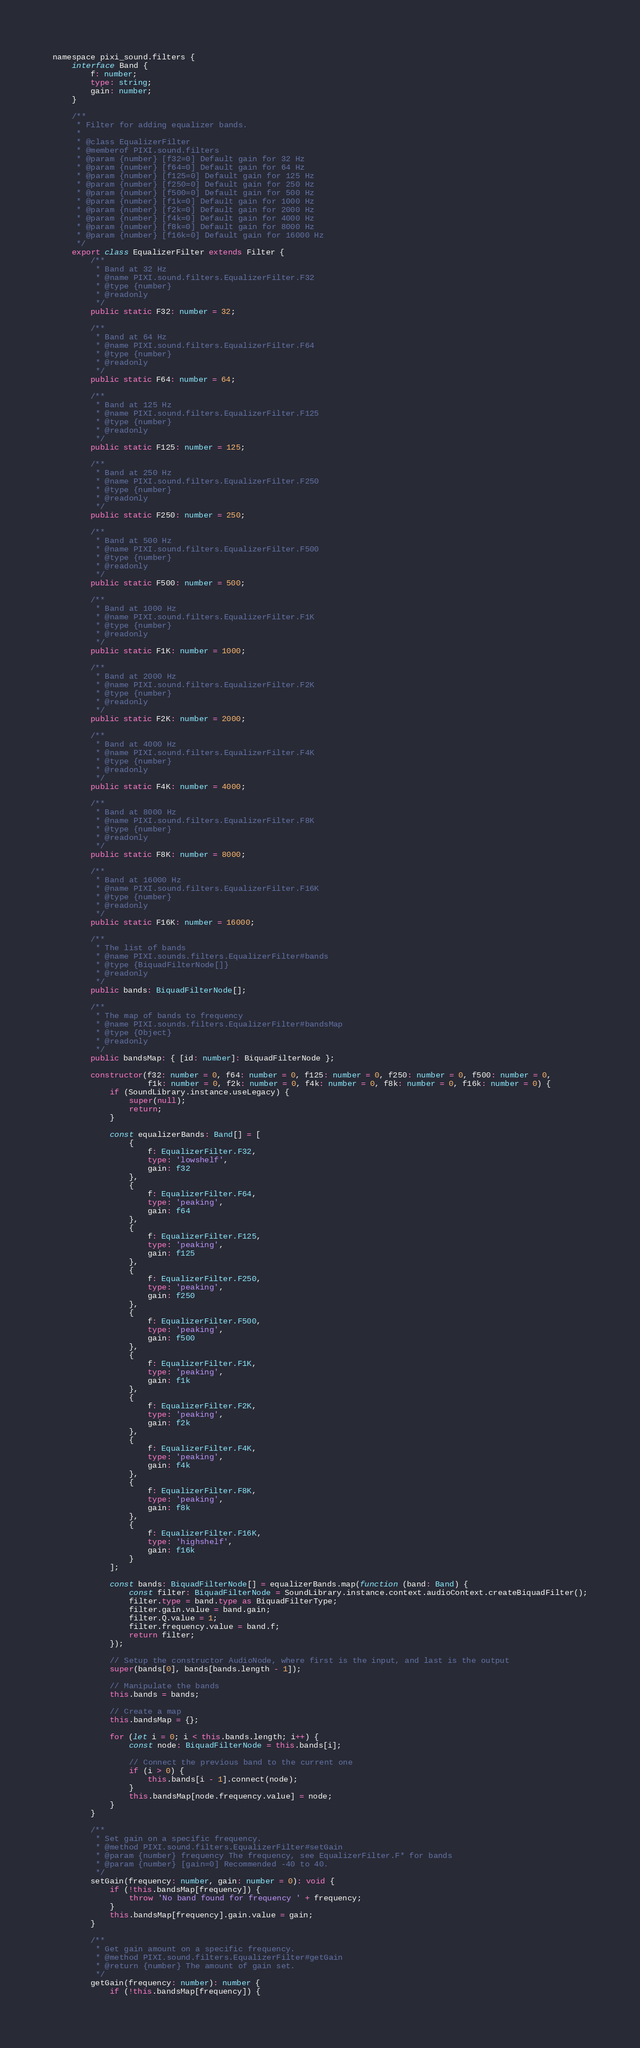Convert code to text. <code><loc_0><loc_0><loc_500><loc_500><_TypeScript_>namespace pixi_sound.filters {
	interface Band {
		f: number;
		type: string;
		gain: number;
	}

	/**
	 * Filter for adding equalizer bands.
	 *
	 * @class EqualizerFilter
	 * @memberof PIXI.sound.filters
	 * @param {number} [f32=0] Default gain for 32 Hz
	 * @param {number} [f64=0] Default gain for 64 Hz
	 * @param {number} [f125=0] Default gain for 125 Hz
	 * @param {number} [f250=0] Default gain for 250 Hz
	 * @param {number} [f500=0] Default gain for 500 Hz
	 * @param {number} [f1k=0] Default gain for 1000 Hz
	 * @param {number} [f2k=0] Default gain for 2000 Hz
	 * @param {number} [f4k=0] Default gain for 4000 Hz
	 * @param {number} [f8k=0] Default gain for 8000 Hz
	 * @param {number} [f16k=0] Default gain for 16000 Hz
	 */
	export class EqualizerFilter extends Filter {
		/**
		 * Band at 32 Hz
		 * @name PIXI.sound.filters.EqualizerFilter.F32
		 * @type {number}
		 * @readonly
		 */
		public static F32: number = 32;

		/**
		 * Band at 64 Hz
		 * @name PIXI.sound.filters.EqualizerFilter.F64
		 * @type {number}
		 * @readonly
		 */
		public static F64: number = 64;

		/**
		 * Band at 125 Hz
		 * @name PIXI.sound.filters.EqualizerFilter.F125
		 * @type {number}
		 * @readonly
		 */
		public static F125: number = 125;

		/**
		 * Band at 250 Hz
		 * @name PIXI.sound.filters.EqualizerFilter.F250
		 * @type {number}
		 * @readonly
		 */
		public static F250: number = 250;

		/**
		 * Band at 500 Hz
		 * @name PIXI.sound.filters.EqualizerFilter.F500
		 * @type {number}
		 * @readonly
		 */
		public static F500: number = 500;

		/**
		 * Band at 1000 Hz
		 * @name PIXI.sound.filters.EqualizerFilter.F1K
		 * @type {number}
		 * @readonly
		 */
		public static F1K: number = 1000;

		/**
		 * Band at 2000 Hz
		 * @name PIXI.sound.filters.EqualizerFilter.F2K
		 * @type {number}
		 * @readonly
		 */
		public static F2K: number = 2000;

		/**
		 * Band at 4000 Hz
		 * @name PIXI.sound.filters.EqualizerFilter.F4K
		 * @type {number}
		 * @readonly
		 */
		public static F4K: number = 4000;

		/**
		 * Band at 8000 Hz
		 * @name PIXI.sound.filters.EqualizerFilter.F8K
		 * @type {number}
		 * @readonly
		 */
		public static F8K: number = 8000;

		/**
		 * Band at 16000 Hz
		 * @name PIXI.sound.filters.EqualizerFilter.F16K
		 * @type {number}
		 * @readonly
		 */
		public static F16K: number = 16000;

		/**
		 * The list of bands
		 * @name PIXI.sounds.filters.EqualizerFilter#bands
		 * @type {BiquadFilterNode[]}
		 * @readonly
		 */
		public bands: BiquadFilterNode[];

		/**
		 * The map of bands to frequency
		 * @name PIXI.sounds.filters.EqualizerFilter#bandsMap
		 * @type {Object}
		 * @readonly
		 */
		public bandsMap: { [id: number]: BiquadFilterNode };

		constructor(f32: number = 0, f64: number = 0, f125: number = 0, f250: number = 0, f500: number = 0,
		            f1k: number = 0, f2k: number = 0, f4k: number = 0, f8k: number = 0, f16k: number = 0) {
			if (SoundLibrary.instance.useLegacy) {
				super(null);
				return;
			}

			const equalizerBands: Band[] = [
				{
					f: EqualizerFilter.F32,
					type: 'lowshelf',
					gain: f32
				},
				{
					f: EqualizerFilter.F64,
					type: 'peaking',
					gain: f64
				},
				{
					f: EqualizerFilter.F125,
					type: 'peaking',
					gain: f125
				},
				{
					f: EqualizerFilter.F250,
					type: 'peaking',
					gain: f250
				},
				{
					f: EqualizerFilter.F500,
					type: 'peaking',
					gain: f500
				},
				{
					f: EqualizerFilter.F1K,
					type: 'peaking',
					gain: f1k
				},
				{
					f: EqualizerFilter.F2K,
					type: 'peaking',
					gain: f2k
				},
				{
					f: EqualizerFilter.F4K,
					type: 'peaking',
					gain: f4k
				},
				{
					f: EqualizerFilter.F8K,
					type: 'peaking',
					gain: f8k
				},
				{
					f: EqualizerFilter.F16K,
					type: 'highshelf',
					gain: f16k
				}
			];

			const bands: BiquadFilterNode[] = equalizerBands.map(function (band: Band) {
				const filter: BiquadFilterNode = SoundLibrary.instance.context.audioContext.createBiquadFilter();
				filter.type = band.type as BiquadFilterType;
				filter.gain.value = band.gain;
				filter.Q.value = 1;
				filter.frequency.value = band.f;
				return filter;
			});

			// Setup the constructor AudioNode, where first is the input, and last is the output
			super(bands[0], bands[bands.length - 1]);

			// Manipulate the bands
			this.bands = bands;

			// Create a map
			this.bandsMap = {};

			for (let i = 0; i < this.bands.length; i++) {
				const node: BiquadFilterNode = this.bands[i];

				// Connect the previous band to the current one
				if (i > 0) {
					this.bands[i - 1].connect(node);
				}
				this.bandsMap[node.frequency.value] = node;
			}
		}

		/**
		 * Set gain on a specific frequency.
		 * @method PIXI.sound.filters.EqualizerFilter#setGain
		 * @param {number} frequency The frequency, see EqualizerFilter.F* for bands
		 * @param {number} [gain=0] Recommended -40 to 40.
		 */
		setGain(frequency: number, gain: number = 0): void {
			if (!this.bandsMap[frequency]) {
				throw 'No band found for frequency ' + frequency;
			}
			this.bandsMap[frequency].gain.value = gain;
		}

		/**
		 * Get gain amount on a specific frequency.
		 * @method PIXI.sound.filters.EqualizerFilter#getGain
		 * @return {number} The amount of gain set.
		 */
		getGain(frequency: number): number {
			if (!this.bandsMap[frequency]) {</code> 